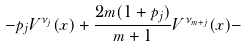<formula> <loc_0><loc_0><loc_500><loc_500>- p _ { j } V ^ { \nu _ { j } } ( x ) + \frac { 2 m ( 1 + p _ { j } ) } { m + 1 } V ^ { \nu _ { m + j } } ( x ) -</formula> 